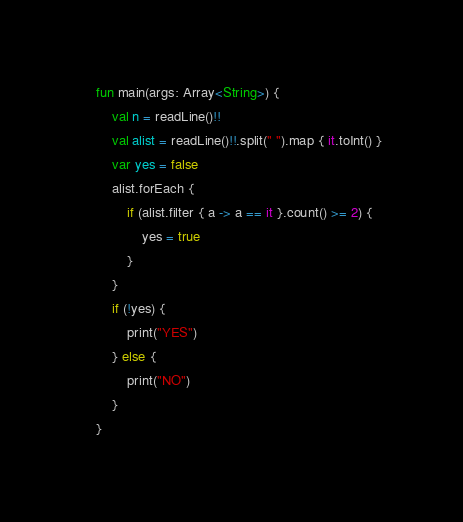<code> <loc_0><loc_0><loc_500><loc_500><_Kotlin_>    fun main(args: Array<String>) {
        val n = readLine()!!
        val alist = readLine()!!.split(" ").map { it.toInt() }
        var yes = false
        alist.forEach { 
            if (alist.filter { a -> a == it }.count() >= 2) {
                yes = true
            }
        }
        if (!yes) {
            print("YES")
        } else {
            print("NO")
        }
    }</code> 